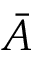<formula> <loc_0><loc_0><loc_500><loc_500>\bar { A }</formula> 